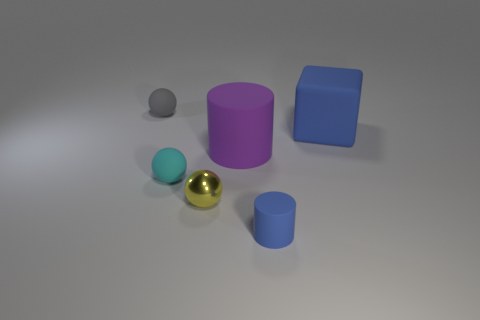Subtract all tiny metallic balls. How many balls are left? 2 Add 3 large red cubes. How many objects exist? 9 Subtract all cylinders. Subtract all red matte cylinders. How many objects are left? 4 Add 1 cyan matte balls. How many cyan matte balls are left? 2 Add 2 small red shiny cylinders. How many small red shiny cylinders exist? 2 Subtract 0 cyan blocks. How many objects are left? 6 Subtract all cubes. How many objects are left? 5 Subtract all brown spheres. Subtract all cyan cylinders. How many spheres are left? 3 